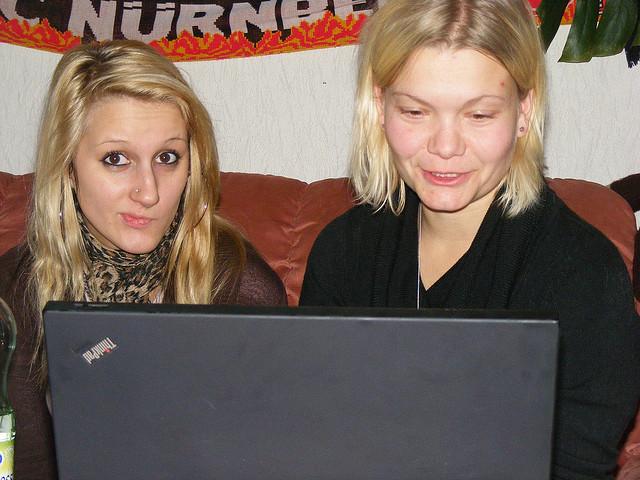What brand is the laptop?
Answer briefly. Thinkpad. Which woman is not looking at the camera?
Be succinct. Left. Are these two people dating?
Give a very brief answer. No. How many ladies are there in the picture?
Answer briefly. 2. 